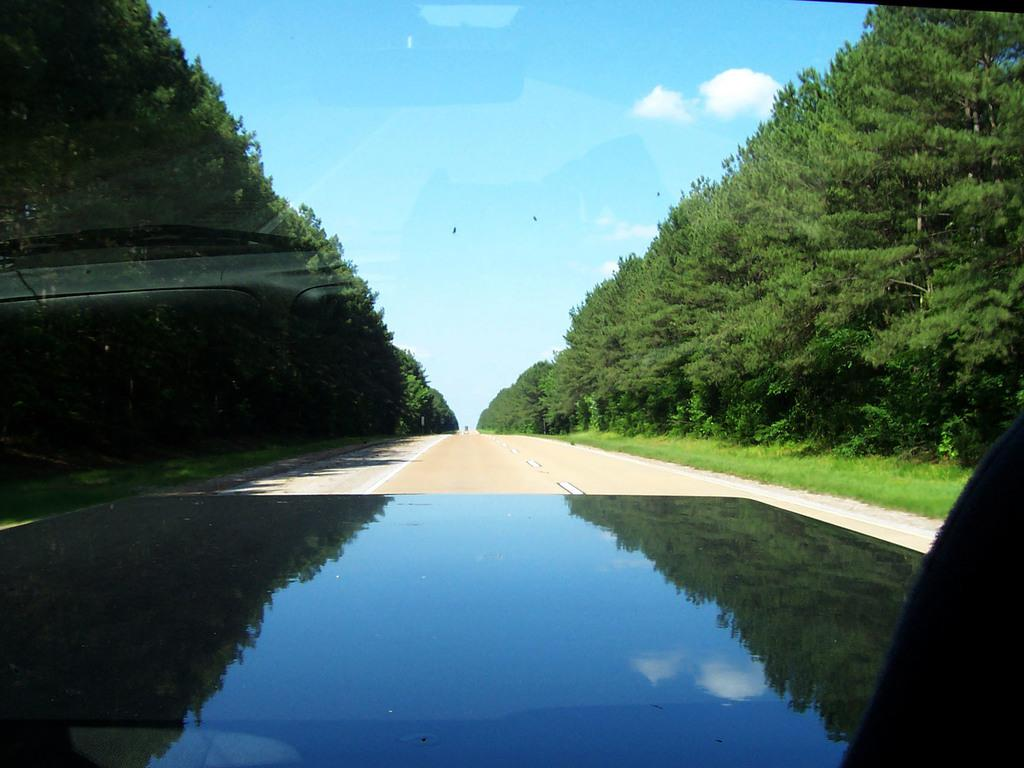What is the main subject of the image? There is a vehicle on the road in the image. What can be seen on both sides of the road in the image? There are many trees on both sides of the road in the image. What is visible in the background of the image? Clouds and the sky are visible in the background of the image. What type of umbrella is the doctor holding in the image? There is no doctor or umbrella present in the image. 